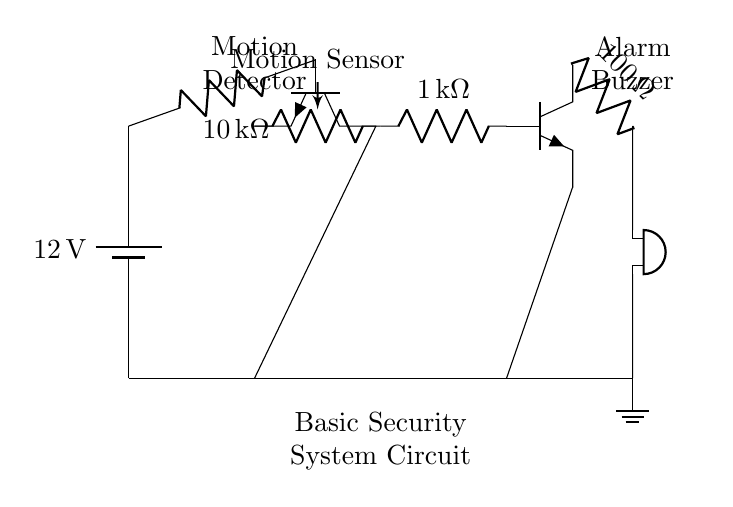What is the voltage of the power supply? The voltage is labeled as twelve volts, which is indicated on the battery symbol in the diagram. This is the potential difference provided by the power supply for the circuit.
Answer: twelve volts What type of sensor is used in this circuit? The circuit diagram indicates the use of a motion sensor, which is specified as "Motion Sensor" next to the relevant component in the drawing. This component is responsible for detecting movement.
Answer: Motion Sensor How many resistors are present in the circuit? There are three resistors shown in the diagram, which are labeled with their resistance values of ten kiloohms, one kiloohm, and one hundred ohms respectively, indicating their contributions to the circuit's behavior.
Answer: three What is the role of the buzzer in this system? The buzzer functions as the alarm mechanism in the circuit. When the motion sensor detects movement and the circuit is completed, the buzzer emits a sound to alert individuals about the detected motion.
Answer: Alarm How is the motion sensor connected to the power supply? The motion sensor is connected through a resistor and then to the power supply, where one end connects to the battery positive terminal. This arrangement allows the sensor to receive the voltage necessary for operation.
Answer: Through a resistor Which component is located at the farthest right in the circuit diagram? The buzzer is the component placed at the farthest right position in the circuit. It serves as the output device that responds to the signals from the preceding components.
Answer: Buzzer 